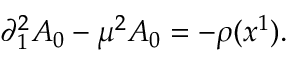Convert formula to latex. <formula><loc_0><loc_0><loc_500><loc_500>\partial _ { 1 } ^ { 2 } A _ { 0 } - \mu ^ { 2 } A _ { 0 } = - \rho ( x ^ { 1 } ) .</formula> 